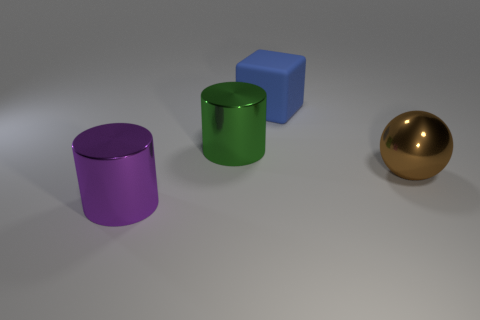Add 4 small gray cubes. How many objects exist? 8 Add 1 large matte blocks. How many large matte blocks exist? 2 Subtract 0 brown cubes. How many objects are left? 4 Subtract all cubes. How many objects are left? 3 Subtract all brown objects. Subtract all purple metallic objects. How many objects are left? 2 Add 1 cubes. How many cubes are left? 2 